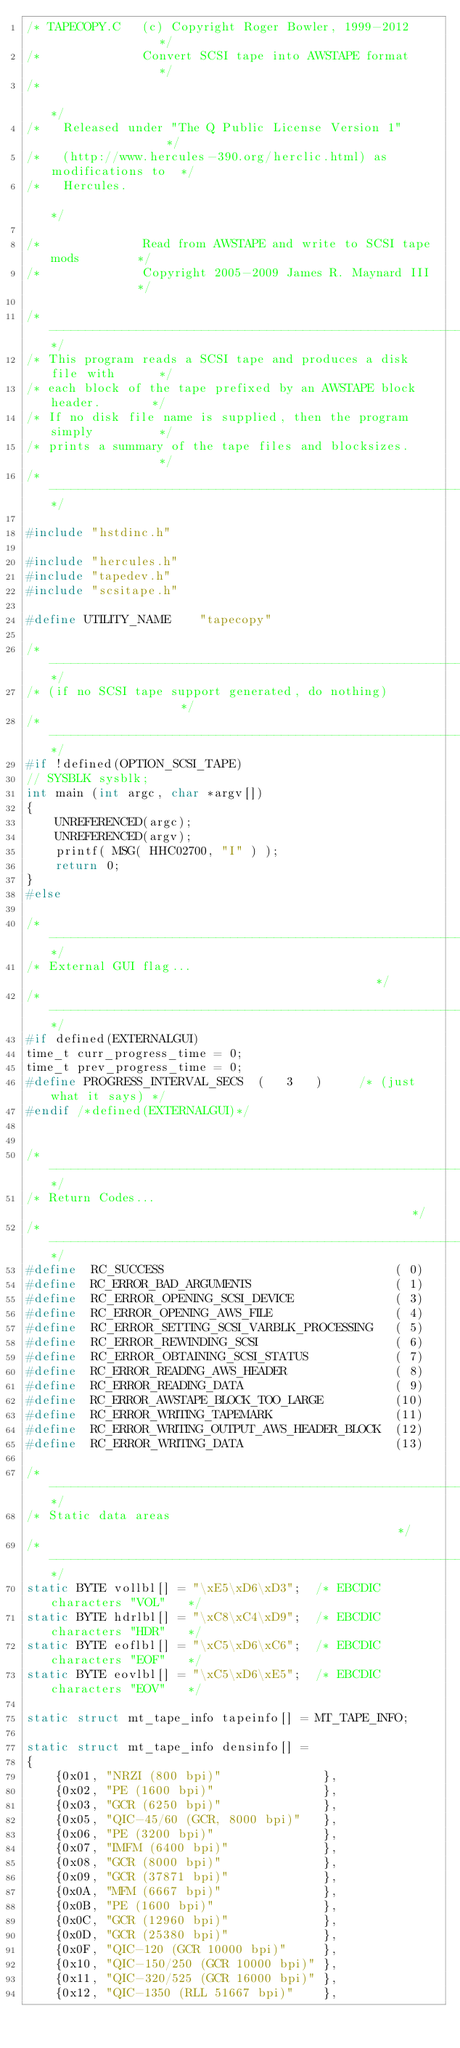<code> <loc_0><loc_0><loc_500><loc_500><_C_>/* TAPECOPY.C   (c) Copyright Roger Bowler, 1999-2012                */
/*              Convert SCSI tape into AWSTAPE format                */
/*                                                                   */
/*   Released under "The Q Public License Version 1"                 */
/*   (http://www.hercules-390.org/herclic.html) as modifications to  */
/*   Hercules.                                                       */

/*              Read from AWSTAPE and write to SCSI tape mods        */
/*              Copyright 2005-2009 James R. Maynard III             */

/*-------------------------------------------------------------------*/
/* This program reads a SCSI tape and produces a disk file with      */
/* each block of the tape prefixed by an AWSTAPE block header.       */
/* If no disk file name is supplied, then the program simply         */
/* prints a summary of the tape files and blocksizes.                */
/*-------------------------------------------------------------------*/

#include "hstdinc.h"

#include "hercules.h"
#include "tapedev.h"
#include "scsitape.h"

#define UTILITY_NAME    "tapecopy"

/*-------------------------------------------------------------------*/
/* (if no SCSI tape support generated, do nothing)                   */
/*-------------------------------------------------------------------*/
#if !defined(OPTION_SCSI_TAPE)
// SYSBLK sysblk;
int main (int argc, char *argv[])
{
    UNREFERENCED(argc);
    UNREFERENCED(argv);
    printf( MSG( HHC02700, "I" ) );
    return 0;
}
#else

/*-------------------------------------------------------------------*/
/* External GUI flag...                                              */
/*-------------------------------------------------------------------*/
#if defined(EXTERNALGUI)
time_t curr_progress_time = 0;
time_t prev_progress_time = 0;
#define PROGRESS_INTERVAL_SECS  (   3   )     /* (just what it says) */
#endif /*defined(EXTERNALGUI)*/


/*-------------------------------------------------------------------*/
/* Return Codes...                                                   */
/*-------------------------------------------------------------------*/
#define  RC_SUCCESS                                ( 0)
#define  RC_ERROR_BAD_ARGUMENTS                    ( 1)
#define  RC_ERROR_OPENING_SCSI_DEVICE              ( 3)
#define  RC_ERROR_OPENING_AWS_FILE                 ( 4)
#define  RC_ERROR_SETTING_SCSI_VARBLK_PROCESSING   ( 5)
#define  RC_ERROR_REWINDING_SCSI                   ( 6)
#define  RC_ERROR_OBTAINING_SCSI_STATUS            ( 7)
#define  RC_ERROR_READING_AWS_HEADER               ( 8)
#define  RC_ERROR_READING_DATA                     ( 9)
#define  RC_ERROR_AWSTAPE_BLOCK_TOO_LARGE          (10)
#define  RC_ERROR_WRITING_TAPEMARK                 (11)
#define  RC_ERROR_WRITING_OUTPUT_AWS_HEADER_BLOCK  (12)
#define  RC_ERROR_WRITING_DATA                     (13)

/*-------------------------------------------------------------------*/
/* Static data areas                                                 */
/*-------------------------------------------------------------------*/
static BYTE vollbl[] = "\xE5\xD6\xD3";  /* EBCDIC characters "VOL"   */
static BYTE hdrlbl[] = "\xC8\xC4\xD9";  /* EBCDIC characters "HDR"   */
static BYTE eoflbl[] = "\xC5\xD6\xC6";  /* EBCDIC characters "EOF"   */
static BYTE eovlbl[] = "\xC5\xD6\xE5";  /* EBCDIC characters "EOV"   */

static struct mt_tape_info tapeinfo[] = MT_TAPE_INFO;

static struct mt_tape_info densinfo[] =
{
    {0x01, "NRZI (800 bpi)"              },
    {0x02, "PE (1600 bpi)"               },
    {0x03, "GCR (6250 bpi)"              },
    {0x05, "QIC-45/60 (GCR, 8000 bpi)"   },
    {0x06, "PE (3200 bpi)"               },
    {0x07, "IMFM (6400 bpi)"             },
    {0x08, "GCR (8000 bpi)"              },
    {0x09, "GCR (37871 bpi)"             },
    {0x0A, "MFM (6667 bpi)"              },
    {0x0B, "PE (1600 bpi)"               },
    {0x0C, "GCR (12960 bpi)"             },
    {0x0D, "GCR (25380 bpi)"             },
    {0x0F, "QIC-120 (GCR 10000 bpi)"     },
    {0x10, "QIC-150/250 (GCR 10000 bpi)" },
    {0x11, "QIC-320/525 (GCR 16000 bpi)" },
    {0x12, "QIC-1350 (RLL 51667 bpi)"    },</code> 